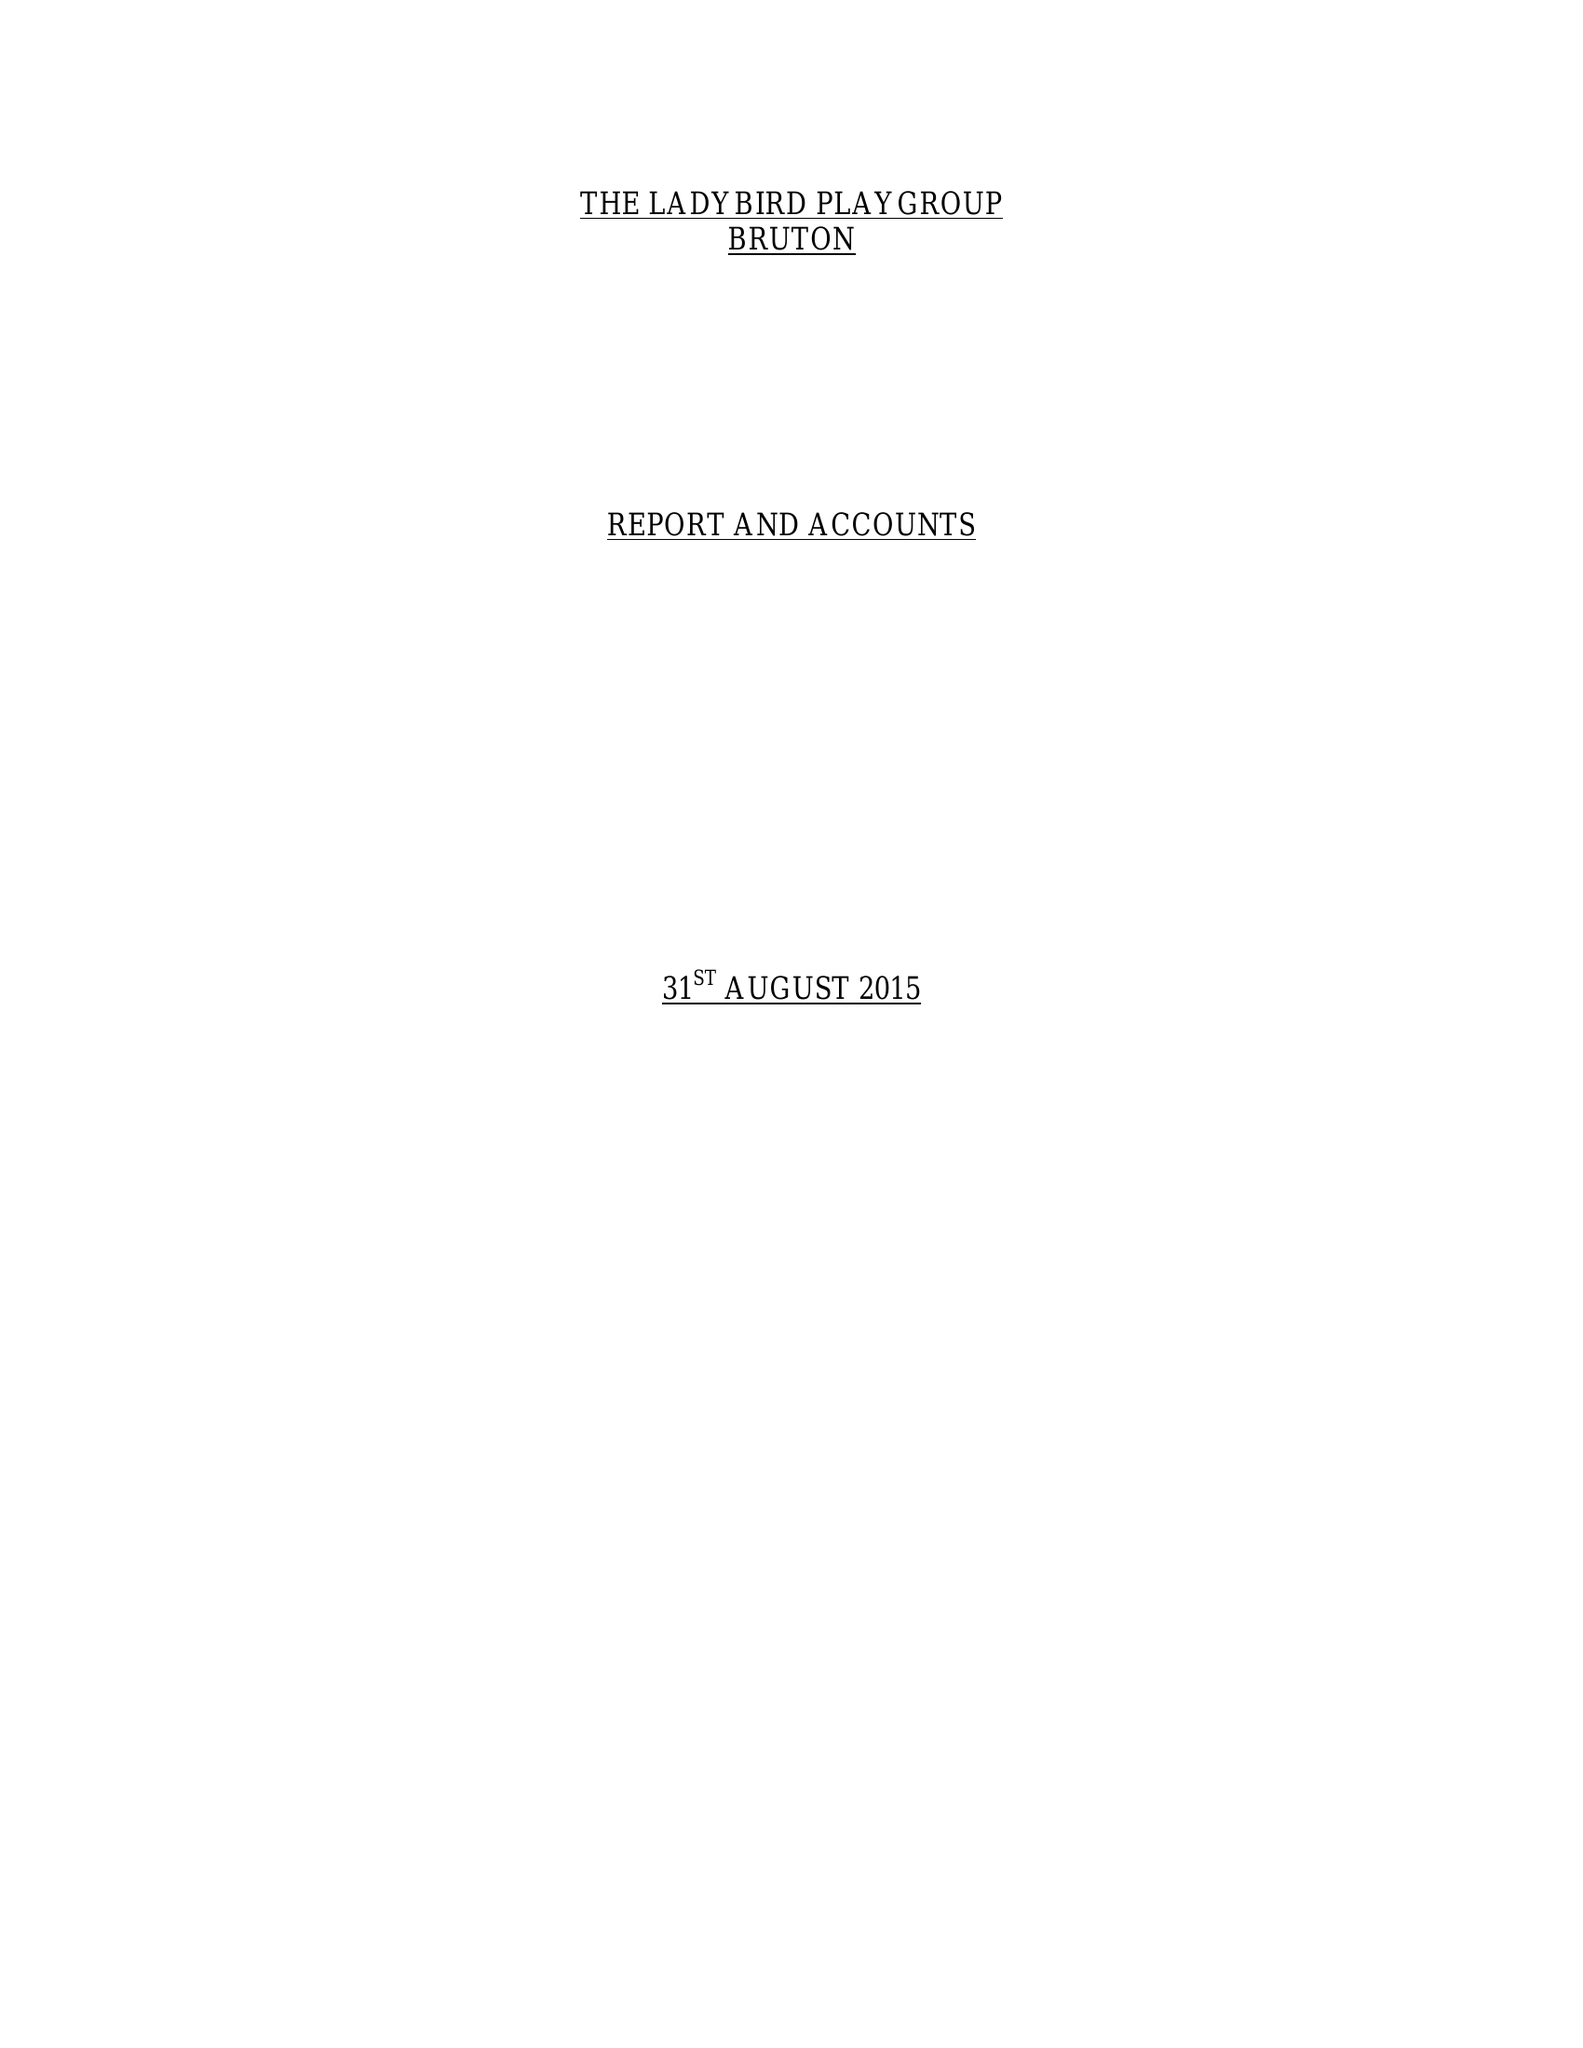What is the value for the address__street_line?
Answer the question using a single word or phrase. GODMINSTER LANE 